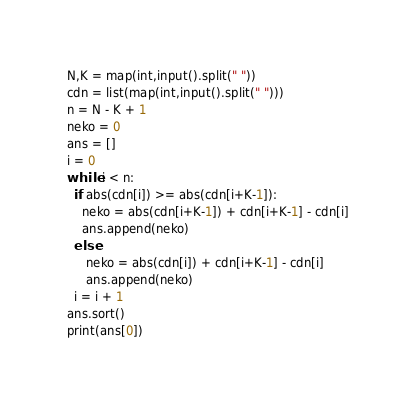<code> <loc_0><loc_0><loc_500><loc_500><_Python_>N,K = map(int,input().split(" "))
cdn = list(map(int,input().split(" ")))
n = N - K + 1
neko = 0
ans = []
i = 0
while i < n:
  if abs(cdn[i]) >= abs(cdn[i+K-1]):
    neko = abs(cdn[i+K-1]) + cdn[i+K-1] - cdn[i]
    ans.append(neko)
  else:
     neko = abs(cdn[i]) + cdn[i+K-1] - cdn[i]
     ans.append(neko)
  i = i + 1
ans.sort()
print(ans[0])</code> 